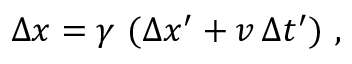Convert formula to latex. <formula><loc_0><loc_0><loc_500><loc_500>\Delta x = \gamma \ ( \Delta x ^ { \prime } + v \, \Delta t ^ { \prime } ) \ ,</formula> 